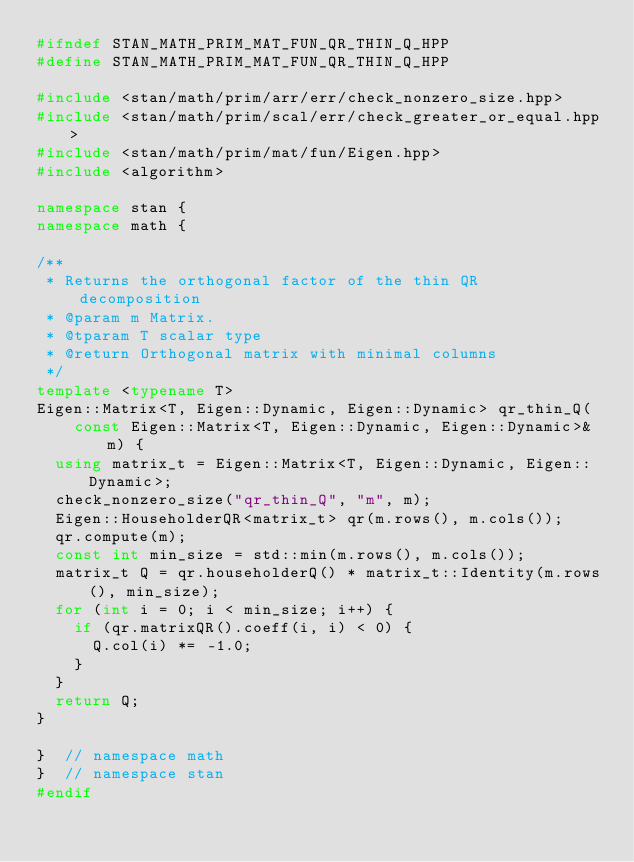<code> <loc_0><loc_0><loc_500><loc_500><_C++_>#ifndef STAN_MATH_PRIM_MAT_FUN_QR_THIN_Q_HPP
#define STAN_MATH_PRIM_MAT_FUN_QR_THIN_Q_HPP

#include <stan/math/prim/arr/err/check_nonzero_size.hpp>
#include <stan/math/prim/scal/err/check_greater_or_equal.hpp>
#include <stan/math/prim/mat/fun/Eigen.hpp>
#include <algorithm>

namespace stan {
namespace math {

/**
 * Returns the orthogonal factor of the thin QR decomposition
 * @param m Matrix.
 * @tparam T scalar type
 * @return Orthogonal matrix with minimal columns
 */
template <typename T>
Eigen::Matrix<T, Eigen::Dynamic, Eigen::Dynamic> qr_thin_Q(
    const Eigen::Matrix<T, Eigen::Dynamic, Eigen::Dynamic>& m) {
  using matrix_t = Eigen::Matrix<T, Eigen::Dynamic, Eigen::Dynamic>;
  check_nonzero_size("qr_thin_Q", "m", m);
  Eigen::HouseholderQR<matrix_t> qr(m.rows(), m.cols());
  qr.compute(m);
  const int min_size = std::min(m.rows(), m.cols());
  matrix_t Q = qr.householderQ() * matrix_t::Identity(m.rows(), min_size);
  for (int i = 0; i < min_size; i++) {
    if (qr.matrixQR().coeff(i, i) < 0) {
      Q.col(i) *= -1.0;
    }
  }
  return Q;
}

}  // namespace math
}  // namespace stan
#endif
</code> 